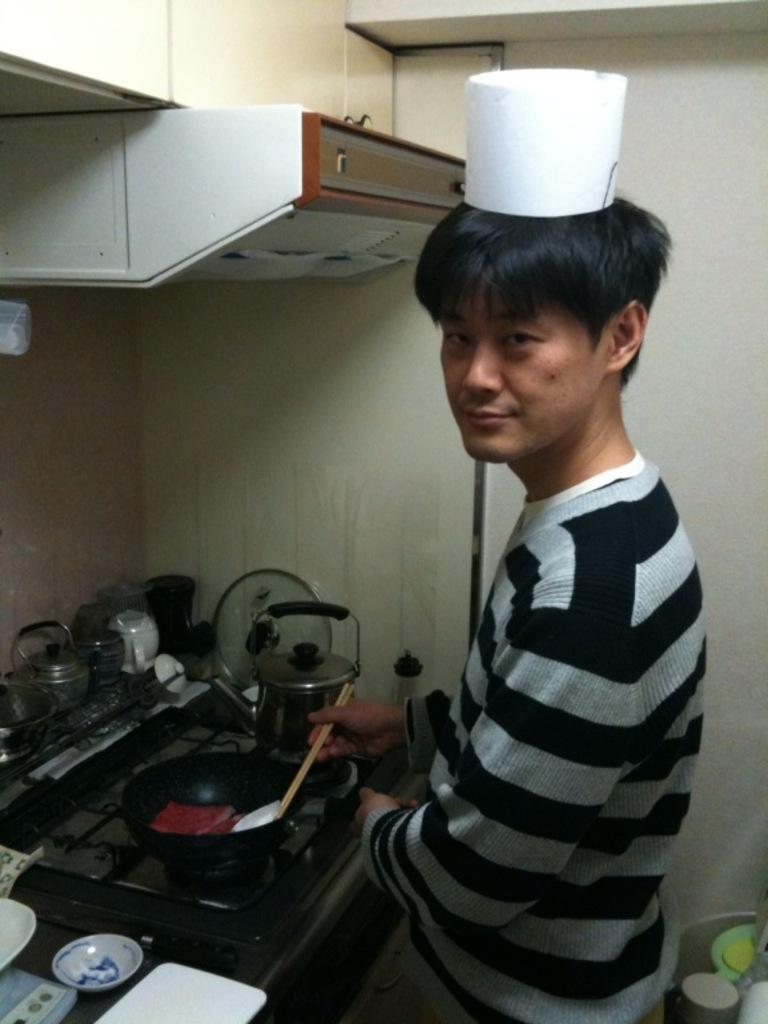Describe this image in one or two sentences. In the middle of the image a man is standing and holding some chopsticks and pan. In the bottom left corner of the image there is a table, on the table there is a stove, bowls and cups. Behind them there is wall, on the wall there is a cupboard. In the bottom right corner of the image there is an object. 